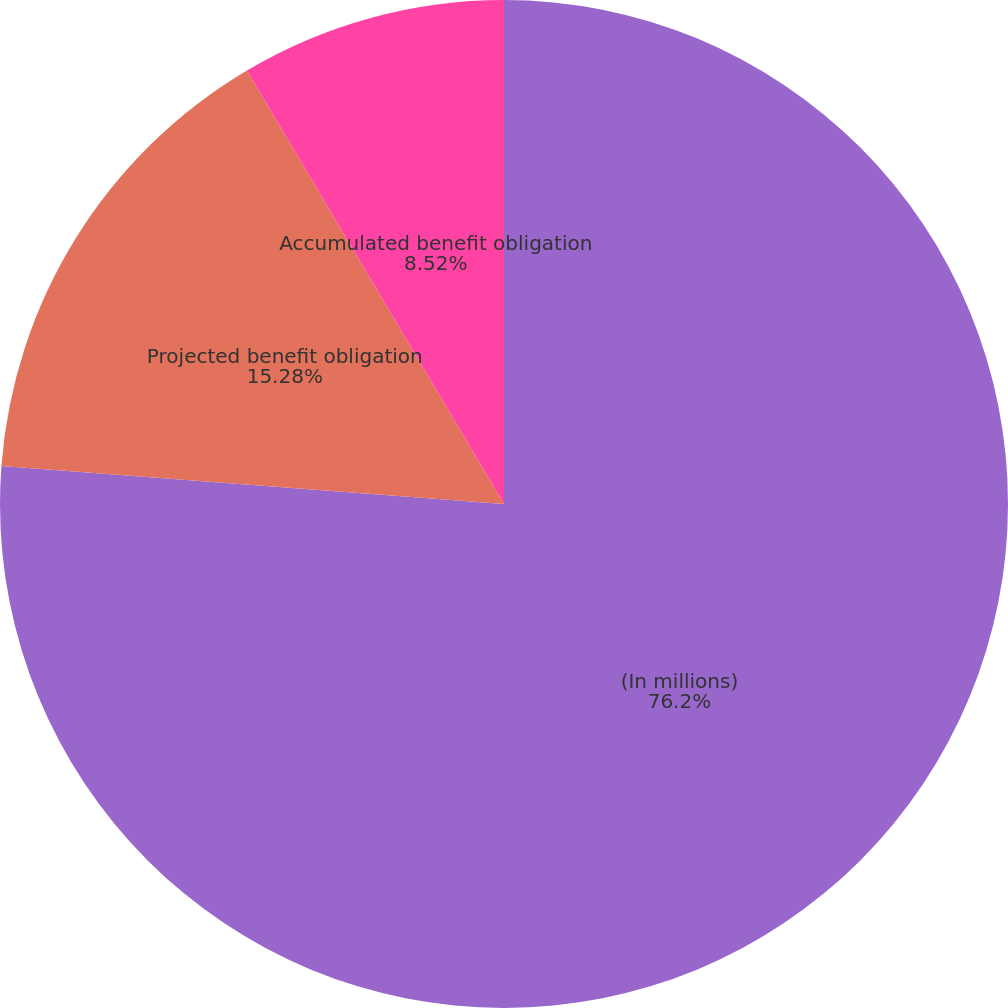<chart> <loc_0><loc_0><loc_500><loc_500><pie_chart><fcel>(In millions)<fcel>Projected benefit obligation<fcel>Accumulated benefit obligation<nl><fcel>76.2%<fcel>15.28%<fcel>8.52%<nl></chart> 